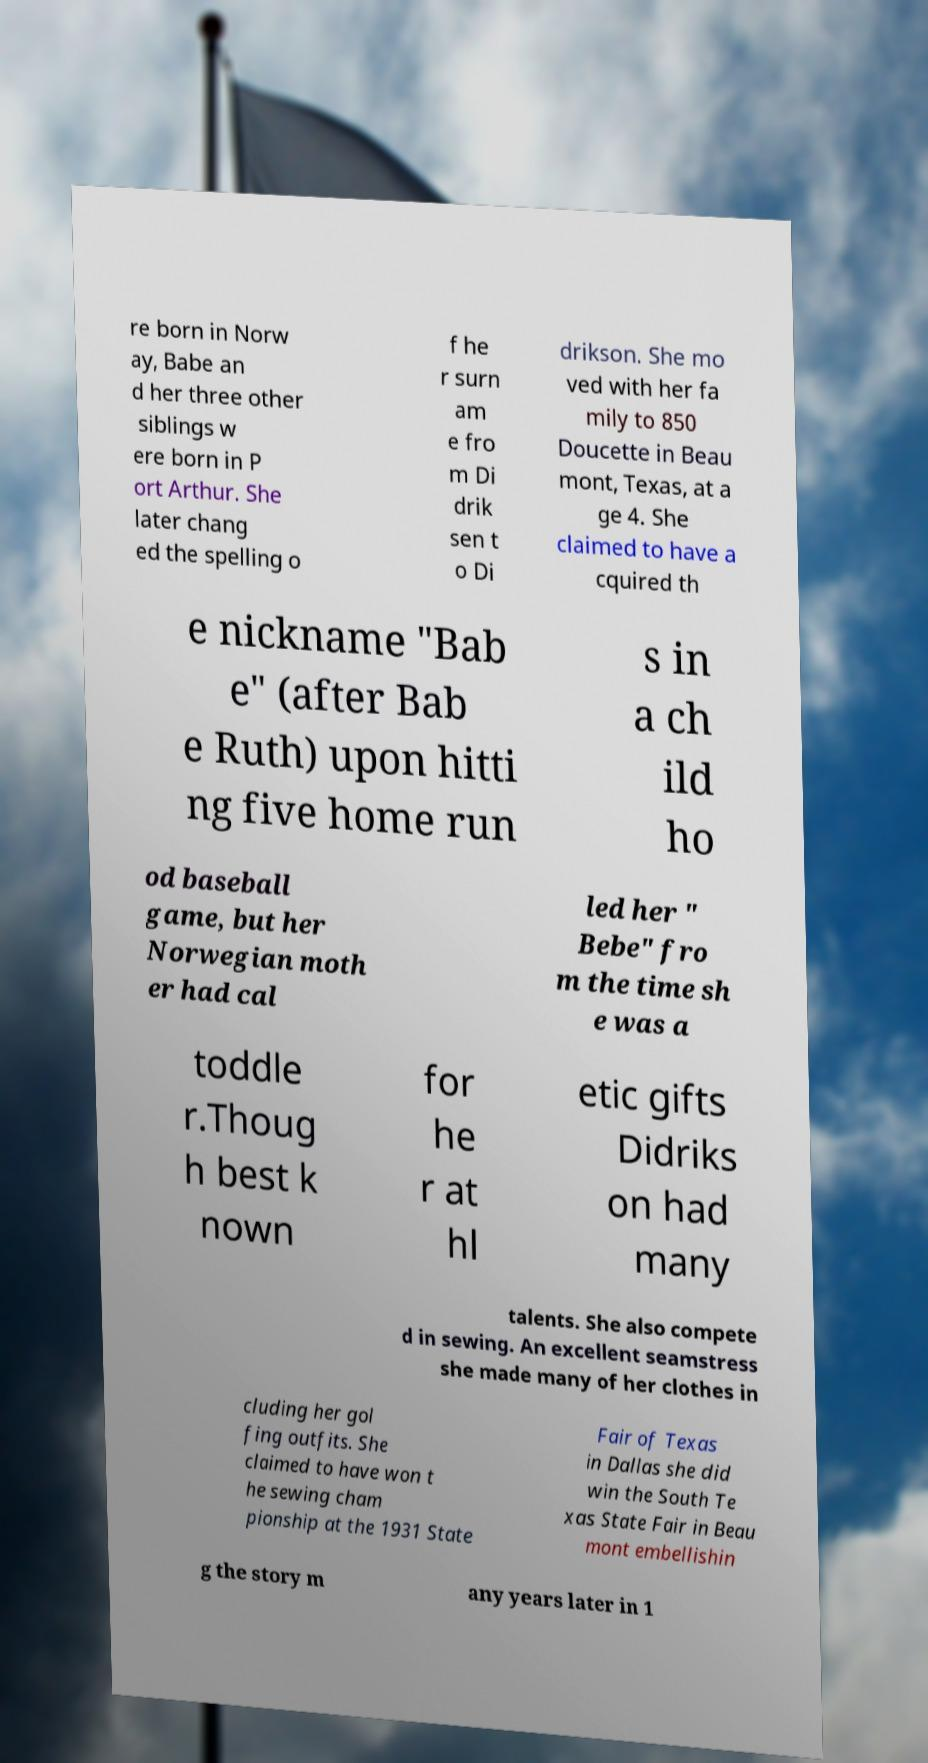Could you extract and type out the text from this image? re born in Norw ay, Babe an d her three other siblings w ere born in P ort Arthur. She later chang ed the spelling o f he r surn am e fro m Di drik sen t o Di drikson. She mo ved with her fa mily to 850 Doucette in Beau mont, Texas, at a ge 4. She claimed to have a cquired th e nickname "Bab e" (after Bab e Ruth) upon hitti ng five home run s in a ch ild ho od baseball game, but her Norwegian moth er had cal led her " Bebe" fro m the time sh e was a toddle r.Thoug h best k nown for he r at hl etic gifts Didriks on had many talents. She also compete d in sewing. An excellent seamstress she made many of her clothes in cluding her gol fing outfits. She claimed to have won t he sewing cham pionship at the 1931 State Fair of Texas in Dallas she did win the South Te xas State Fair in Beau mont embellishin g the story m any years later in 1 